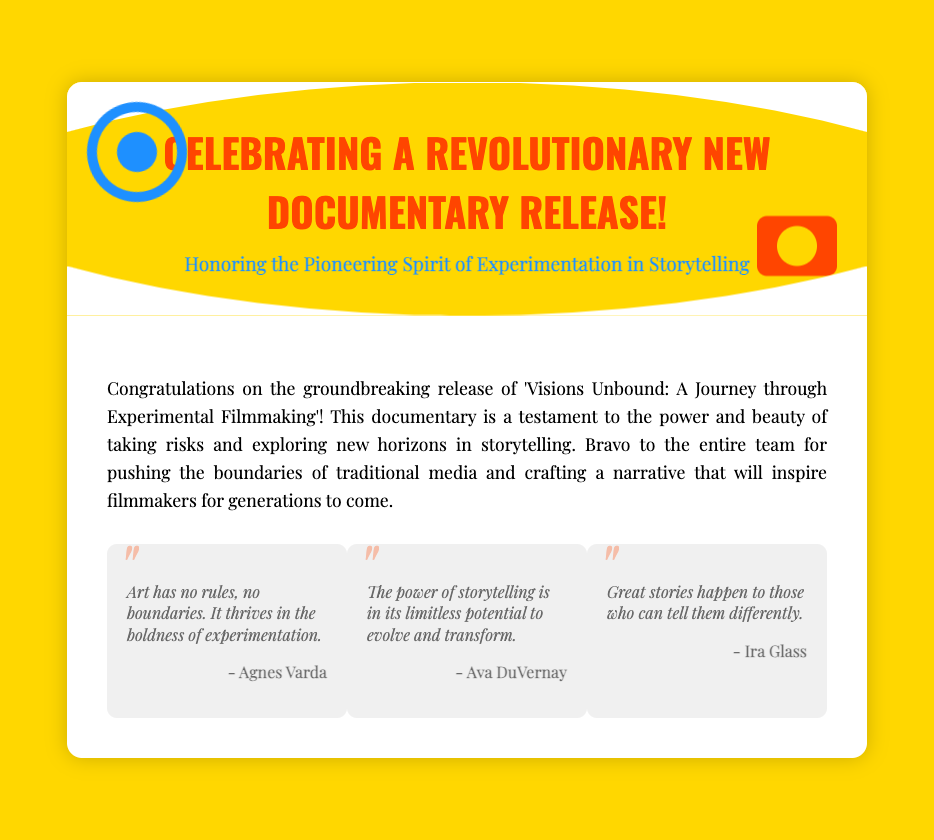What is the title of the documentary? The title is prominently displayed in the document and is 'Visions Unbound: A Journey through Experimental Filmmaking'.
Answer: Visions Unbound: A Journey through Experimental Filmmaking Who is the first quoted author? The first quoted author is identified in the quotes section of the document.
Answer: Agnes Varda What kind of spirit does the card honor? The card clearly mentions the spirit it honors in the subtitle.
Answer: Pioneering Spirit What color is the background of the greeting card? The background color is specified in the document's styles.
Answer: Gold How many quotes are included in the document? The number of quotes can be counted in the quotes section of the card.
Answer: Three What is the main theme of the documentary mentioned in the message? The theme is outlined in the brief congratulatory message near the top of the document.
Answer: Experimental Filmmaking What is the message's tone toward the documentary team? The tone can be discerned from the overall congratulatory nature of the message in the document.
Answer: Celebratory What animation is applied to the film reel graphic? The animation detail is specified in the CSS within the document.
Answer: Spin What color is used for the text of the main heading? The color for the heading is indicated in the CSS styles within the document.
Answer: Orange 